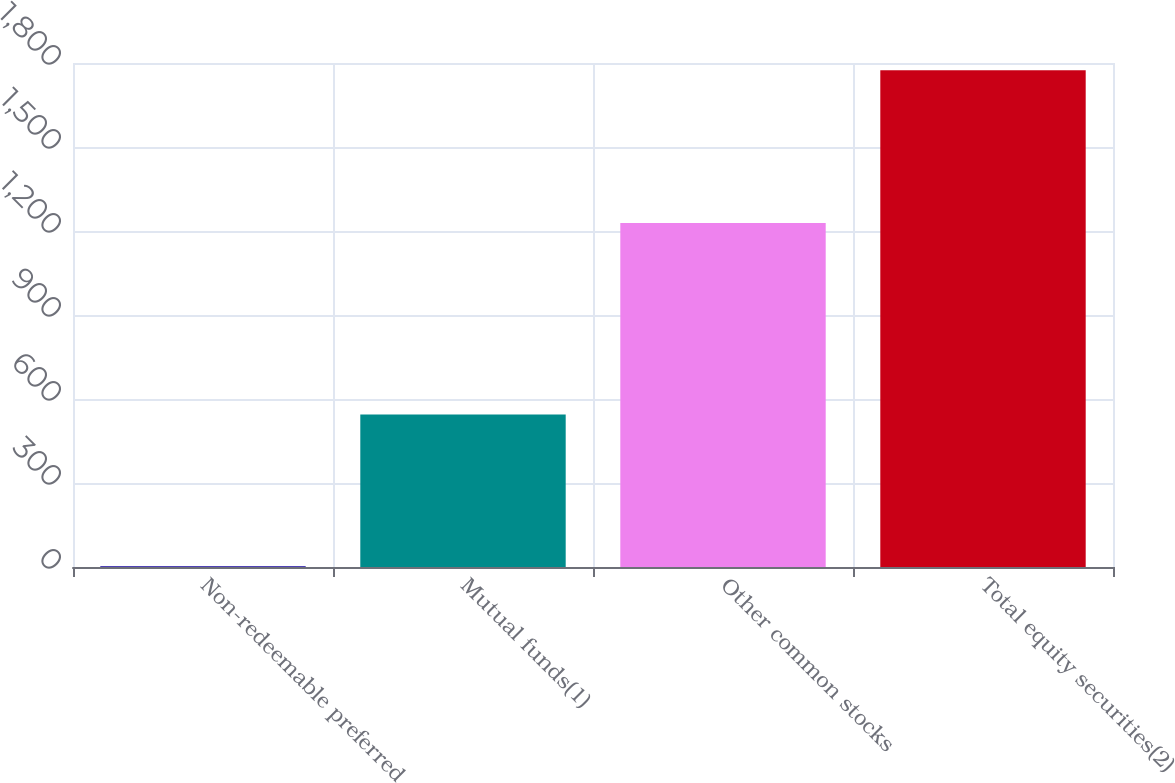Convert chart. <chart><loc_0><loc_0><loc_500><loc_500><bar_chart><fcel>Non-redeemable preferred<fcel>Mutual funds(1)<fcel>Other common stocks<fcel>Total equity securities(2)<nl><fcel>3.25<fcel>545<fcel>1229<fcel>1774<nl></chart> 